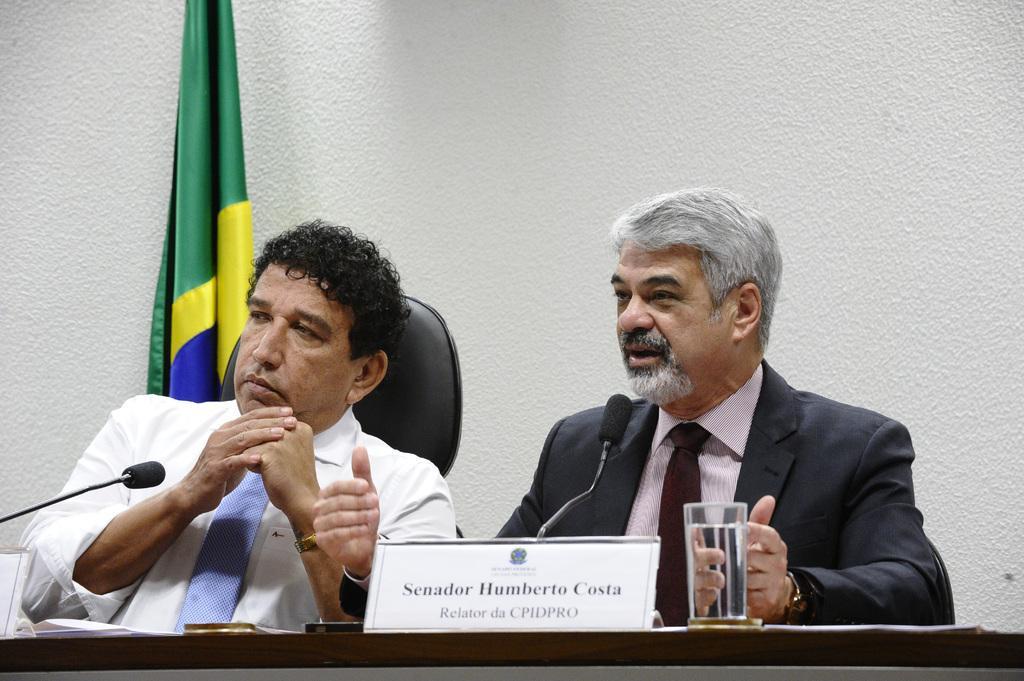How would you summarize this image in a sentence or two? In this image I can see two men are sitting on chairs. I can also see few mics, a glass, a board and on this board I can see something is written. In background I can see green colour flag and white colour wall. 